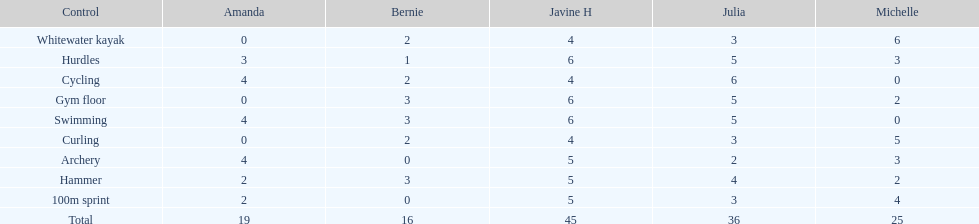What is the average score on 100m sprint? 2.8. 